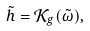Convert formula to latex. <formula><loc_0><loc_0><loc_500><loc_500>\tilde { h } = \mathcal { K } _ { g } ( \tilde { \omega } ) ,</formula> 